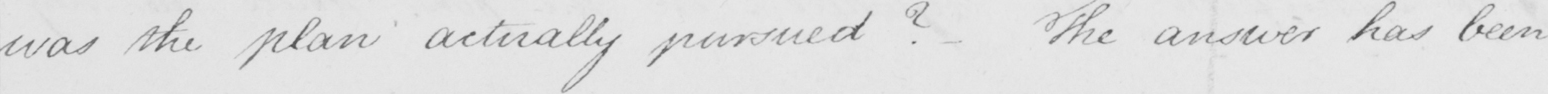Can you tell me what this handwritten text says? was the plan actually pursued ?  The answer has been 